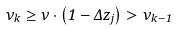<formula> <loc_0><loc_0><loc_500><loc_500>\nu _ { k } \geq \nu \cdot \left ( 1 - \Delta z _ { j } \right ) > \nu _ { k - 1 }</formula> 